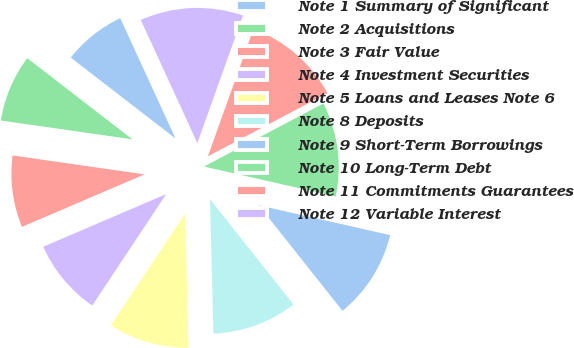Convert chart to OTSL. <chart><loc_0><loc_0><loc_500><loc_500><pie_chart><fcel>Note 1 Summary of Significant<fcel>Note 2 Acquisitions<fcel>Note 3 Fair Value<fcel>Note 4 Investment Securities<fcel>Note 5 Loans and Leases Note 6<fcel>Note 8 Deposits<fcel>Note 9 Short-Term Borrowings<fcel>Note 10 Long-Term Debt<fcel>Note 11 Commitments Guarantees<fcel>Note 12 Variable Interest<nl><fcel>7.68%<fcel>8.2%<fcel>8.71%<fcel>9.23%<fcel>9.74%<fcel>10.26%<fcel>10.77%<fcel>11.29%<fcel>11.8%<fcel>12.32%<nl></chart> 